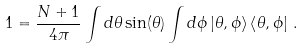Convert formula to latex. <formula><loc_0><loc_0><loc_500><loc_500>1 = \frac { N + 1 } { 4 \pi } \int d \theta \sin ( \theta ) \int d \phi \left | \theta , \phi \right > \left < \theta , \phi \right | \, .</formula> 